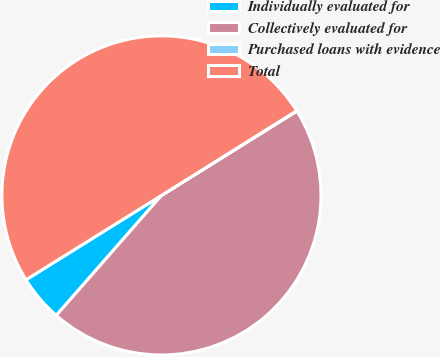Convert chart. <chart><loc_0><loc_0><loc_500><loc_500><pie_chart><fcel>Individually evaluated for<fcel>Collectively evaluated for<fcel>Purchased loans with evidence<fcel>Total<nl><fcel>4.68%<fcel>45.32%<fcel>0.04%<fcel>49.96%<nl></chart> 